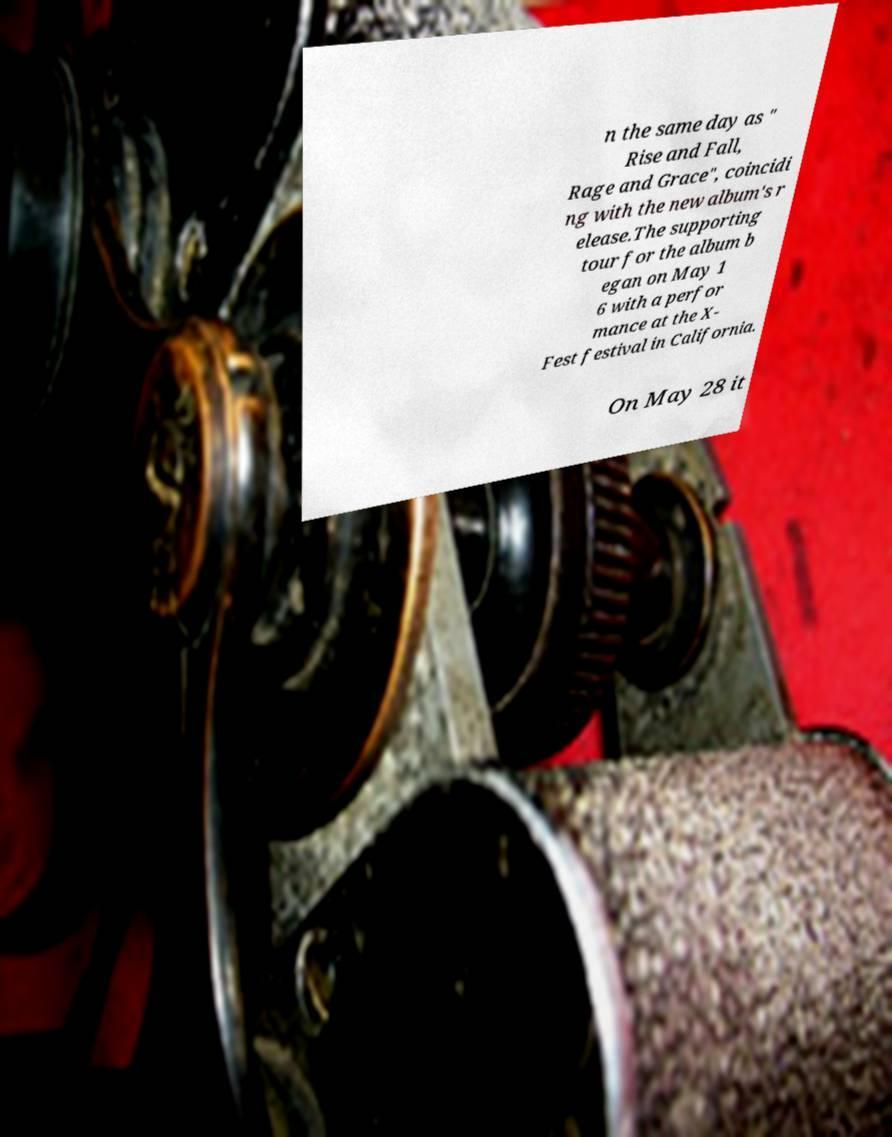Please read and relay the text visible in this image. What does it say? n the same day as " Rise and Fall, Rage and Grace", coincidi ng with the new album's r elease.The supporting tour for the album b egan on May 1 6 with a perfor mance at the X- Fest festival in California. On May 28 it 